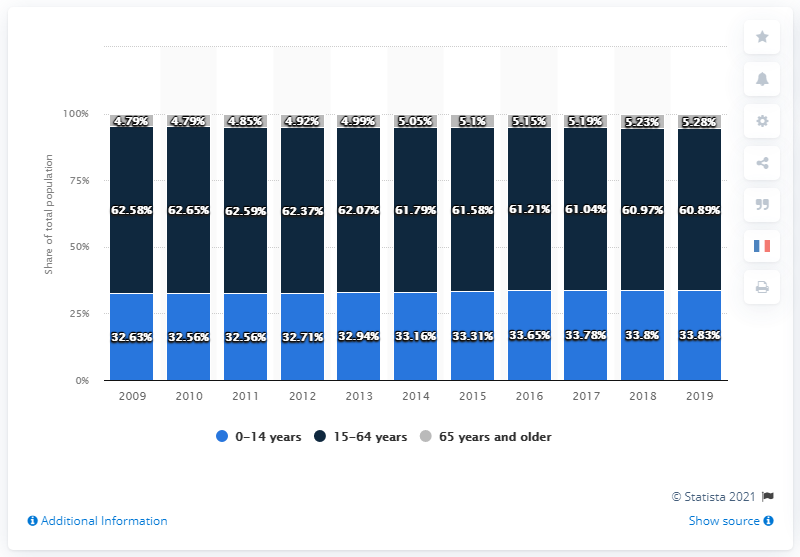Draw attention to some important aspects in this diagram. In 2019, approximately 33.83% of Egypt's population fell within the age group of 0 to 14. 